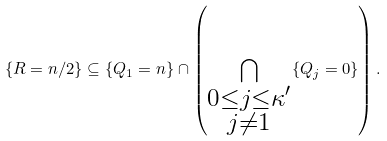Convert formula to latex. <formula><loc_0><loc_0><loc_500><loc_500>\left \{ R = n / 2 \right \} \subseteq \{ Q _ { 1 } = n \} \cap \left ( \bigcap _ { \substack { 0 \leq j \leq \kappa ^ { \prime } \\ j \neq 1 } } \{ Q _ { j } = 0 \} \right ) .</formula> 